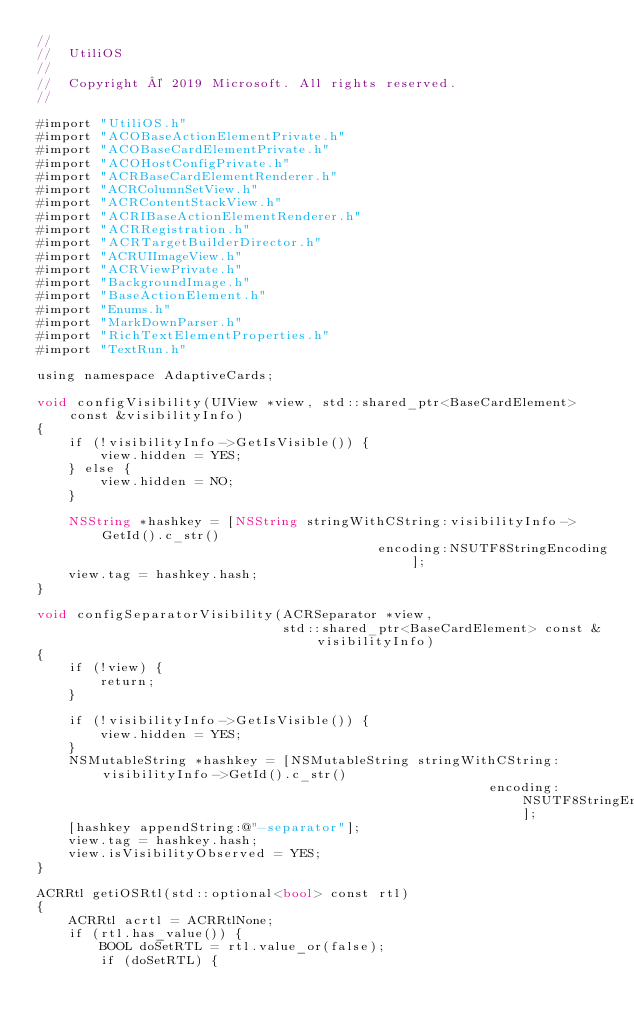<code> <loc_0><loc_0><loc_500><loc_500><_ObjectiveC_>//
//  UtiliOS
//
//  Copyright © 2019 Microsoft. All rights reserved.
//

#import "UtiliOS.h"
#import "ACOBaseActionElementPrivate.h"
#import "ACOBaseCardElementPrivate.h"
#import "ACOHostConfigPrivate.h"
#import "ACRBaseCardElementRenderer.h"
#import "ACRColumnSetView.h"
#import "ACRContentStackView.h"
#import "ACRIBaseActionElementRenderer.h"
#import "ACRRegistration.h"
#import "ACRTargetBuilderDirector.h"
#import "ACRUIImageView.h"
#import "ACRViewPrivate.h"
#import "BackgroundImage.h"
#import "BaseActionElement.h"
#import "Enums.h"
#import "MarkDownParser.h"
#import "RichTextElementProperties.h"
#import "TextRun.h"

using namespace AdaptiveCards;

void configVisibility(UIView *view, std::shared_ptr<BaseCardElement> const &visibilityInfo)
{
    if (!visibilityInfo->GetIsVisible()) {
        view.hidden = YES;
    } else {
        view.hidden = NO;
    }

    NSString *hashkey = [NSString stringWithCString:visibilityInfo->GetId().c_str()
                                           encoding:NSUTF8StringEncoding];
    view.tag = hashkey.hash;
}

void configSeparatorVisibility(ACRSeparator *view,
                               std::shared_ptr<BaseCardElement> const &visibilityInfo)
{
    if (!view) {
        return;
    }

    if (!visibilityInfo->GetIsVisible()) {
        view.hidden = YES;
    }
    NSMutableString *hashkey = [NSMutableString stringWithCString:visibilityInfo->GetId().c_str()
                                                         encoding:NSUTF8StringEncoding];
    [hashkey appendString:@"-separator"];
    view.tag = hashkey.hash;
    view.isVisibilityObserved = YES;
}

ACRRtl getiOSRtl(std::optional<bool> const rtl)
{
    ACRRtl acrtl = ACRRtlNone;
    if (rtl.has_value()) {
        BOOL doSetRTL = rtl.value_or(false);
        if (doSetRTL) {</code> 